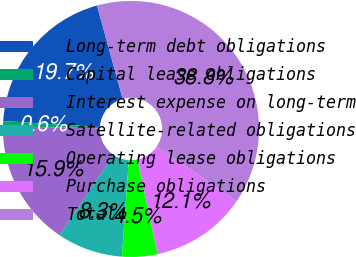Convert chart. <chart><loc_0><loc_0><loc_500><loc_500><pie_chart><fcel>Long-term debt obligations<fcel>Capital lease obligations<fcel>Interest expense on long-term<fcel>Satellite-related obligations<fcel>Operating lease obligations<fcel>Purchase obligations<fcel>Total<nl><fcel>19.74%<fcel>0.65%<fcel>15.92%<fcel>8.28%<fcel>4.47%<fcel>12.1%<fcel>38.84%<nl></chart> 